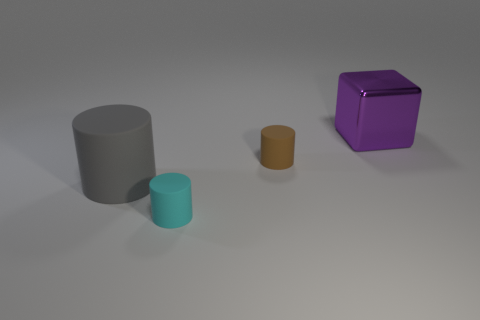Subtract all tiny cylinders. How many cylinders are left? 1 Add 2 large gray rubber cylinders. How many objects exist? 6 Subtract all cylinders. How many objects are left? 1 Subtract 0 red spheres. How many objects are left? 4 Subtract all brown objects. Subtract all brown matte cylinders. How many objects are left? 2 Add 3 purple objects. How many purple objects are left? 4 Add 2 large red shiny cylinders. How many large red shiny cylinders exist? 2 